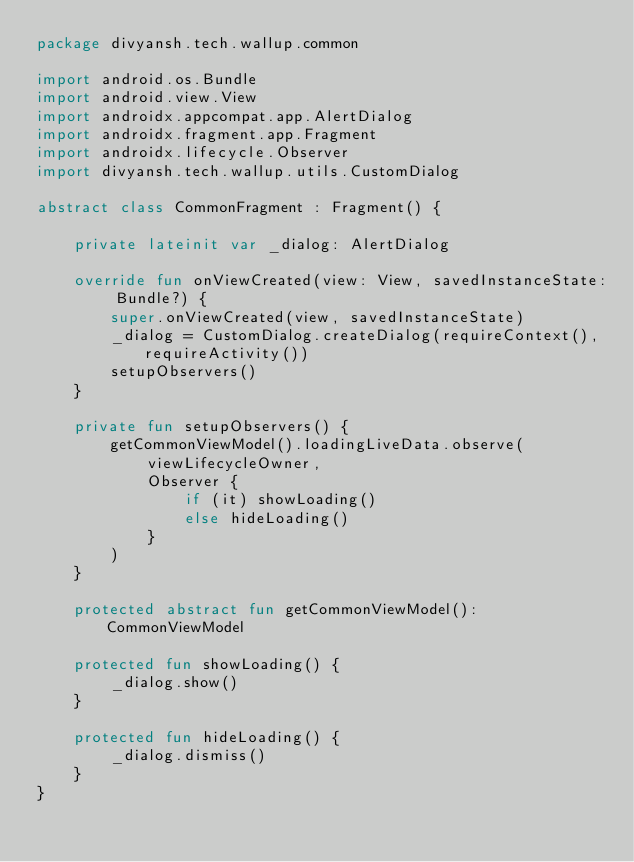Convert code to text. <code><loc_0><loc_0><loc_500><loc_500><_Kotlin_>package divyansh.tech.wallup.common

import android.os.Bundle
import android.view.View
import androidx.appcompat.app.AlertDialog
import androidx.fragment.app.Fragment
import androidx.lifecycle.Observer
import divyansh.tech.wallup.utils.CustomDialog

abstract class CommonFragment : Fragment() {

    private lateinit var _dialog: AlertDialog

    override fun onViewCreated(view: View, savedInstanceState: Bundle?) {
        super.onViewCreated(view, savedInstanceState)
        _dialog = CustomDialog.createDialog(requireContext(), requireActivity())
        setupObservers()
    }

    private fun setupObservers() {
        getCommonViewModel().loadingLiveData.observe(
            viewLifecycleOwner,
            Observer {
                if (it) showLoading()
                else hideLoading()
            }
        )
    }

    protected abstract fun getCommonViewModel(): CommonViewModel

    protected fun showLoading() {
        _dialog.show()
    }

    protected fun hideLoading() {
        _dialog.dismiss()
    }
}</code> 